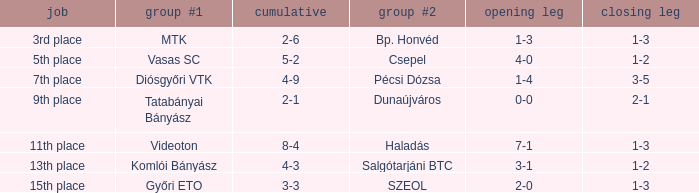What is the team #1 with an 11th place position? Videoton. 